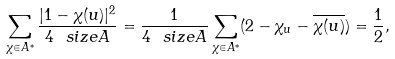<formula> <loc_0><loc_0><loc_500><loc_500>\sum _ { \chi \in A ^ { * } } \frac { | 1 - \chi ( u ) | ^ { 2 } } { 4 \ s i z e { A } } = \frac { 1 } { 4 \ s i z e { A } } \sum _ { \chi \in A ^ { * } } ( 2 - \chi _ { u } - \overline { \chi ( u ) } ) = \frac { 1 } { 2 } ,</formula> 